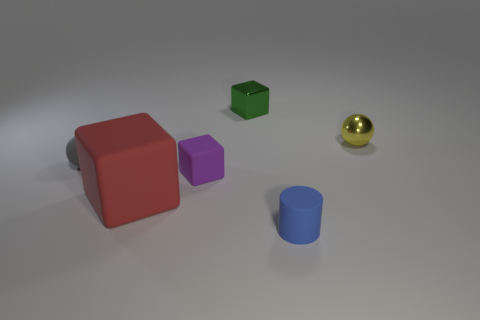What material is the big red cube?
Offer a terse response. Rubber. There is a sphere that is to the left of the purple matte cube; is its size the same as the large block?
Provide a short and direct response. No. Is there any other thing that has the same size as the red rubber object?
Give a very brief answer. No. There is a red rubber thing that is the same shape as the small purple rubber object; what size is it?
Keep it short and to the point. Large. Are there an equal number of small blocks that are on the right side of the tiny green metallic thing and tiny spheres left of the tiny gray sphere?
Provide a short and direct response. Yes. There is a rubber block that is behind the large rubber block; what is its size?
Keep it short and to the point. Small. Are there any other things that are the same shape as the small blue object?
Keep it short and to the point. No. Are there an equal number of small shiny blocks in front of the purple thing and matte things?
Offer a terse response. No. There is a gray matte object; are there any blue rubber cylinders behind it?
Make the answer very short. No. Do the yellow object and the small shiny object behind the tiny yellow thing have the same shape?
Keep it short and to the point. No. 